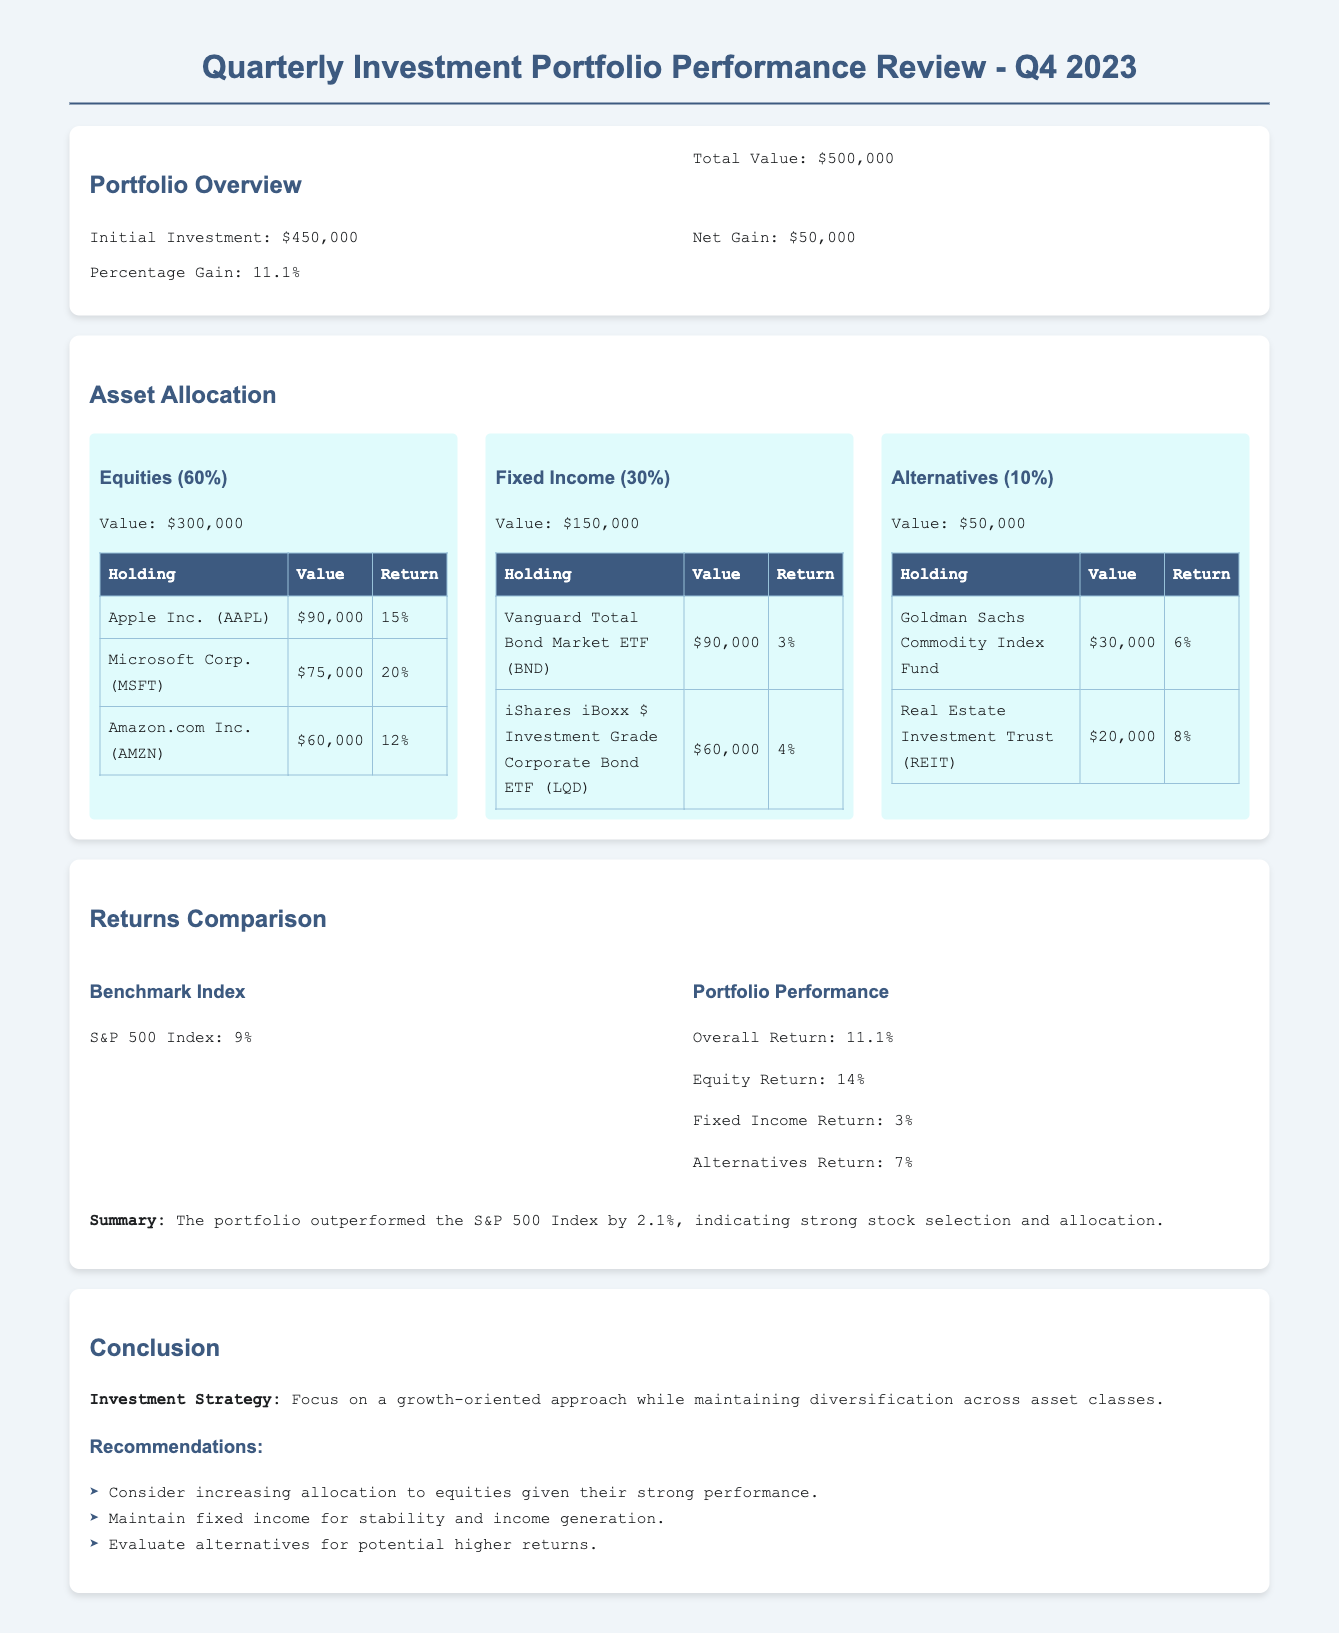What is the total value of the portfolio? The total value of the portfolio is clearly stated in the document as $500,000.
Answer: $500,000 What is the percentage gain of the portfolio? The document specifies the percentage gain of the portfolio as 11.1%.
Answer: 11.1% How much was the initial investment? The initial investment figure provided in the document is $450,000.
Answer: $450,000 What is the return for Apple Inc.? The return for Apple Inc. is listed in the asset allocation section as 15%.
Answer: 15% What is the overall return of the portfolio? The overall return of the portfolio is mentioned as 11.1%.
Answer: 11.1% Which asset class has the highest allocation? The asset class with the highest allocation, according to the document, is Equities at 60%.
Answer: Equities (60%) By how much did the portfolio outperform the S&P 500 Index? The document indicates that the portfolio outperformed the S&P 500 Index by 2.1%.
Answer: 2.1% What is the return of the Fixed Income asset class? The return of the Fixed Income asset class is reported as 3%.
Answer: 3% What is the recommended strategy in the conclusion? The document recommends a growth-oriented approach while maintaining diversification.
Answer: Growth-oriented approach What is the value of the Alternatives asset class? The value of the Alternatives asset class is stated as $50,000.
Answer: $50,000 